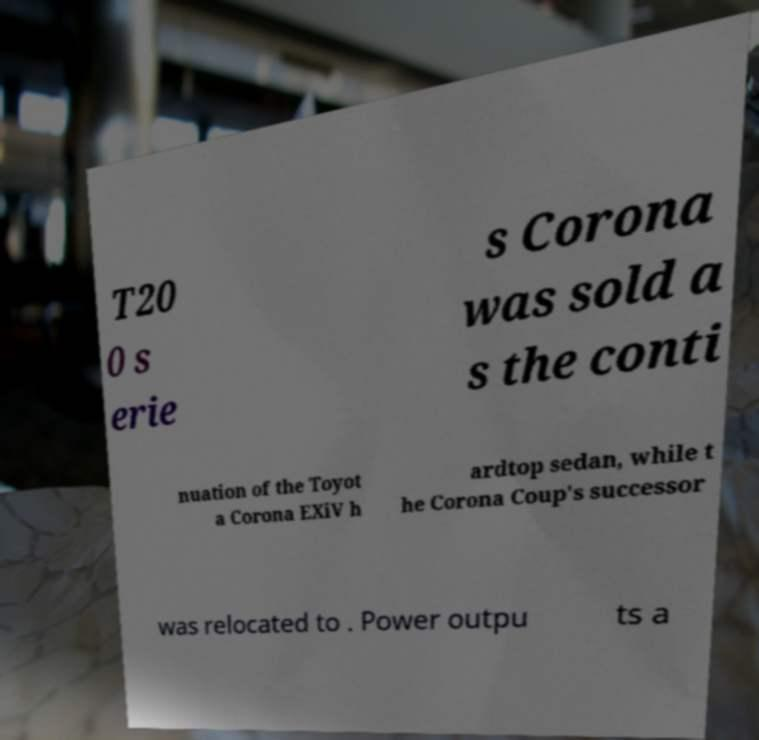For documentation purposes, I need the text within this image transcribed. Could you provide that? T20 0 s erie s Corona was sold a s the conti nuation of the Toyot a Corona EXiV h ardtop sedan, while t he Corona Coup's successor was relocated to . Power outpu ts a 